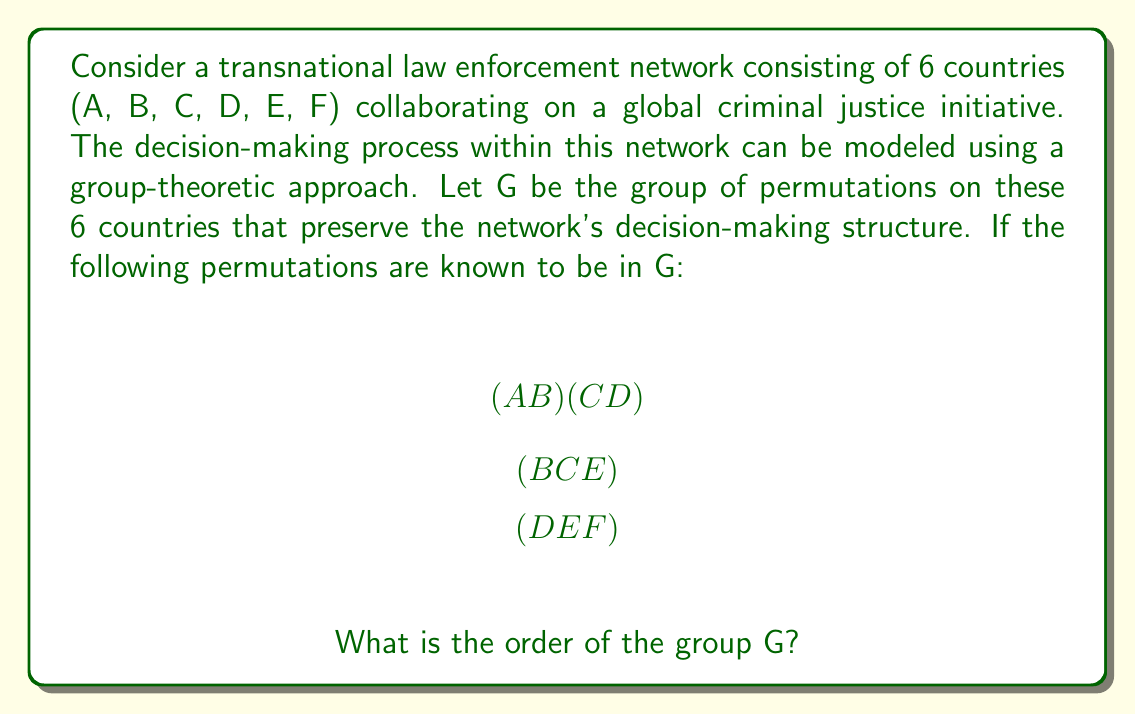Can you answer this question? To solve this problem, we need to analyze the given permutations and determine the full structure of the group G. Let's approach this step-by-step:

1. First, we identify the generators of the group:
   $\alpha = (A B)(C D)$
   $\beta = (B C E)$
   $\gamma = (D E F)$

2. We need to find all elements generated by these permutations. Let's start by computing their powers:

   $\alpha^2 = e$ (identity)
   $\beta^3 = e$
   $\gamma^3 = e$

3. Now, let's consider the products of these permutations:

   $\alpha \beta = (A B)(C D)(B C E) = (A C E B D)$
   $\alpha \gamma = (A B)(C D)(D E F) = (A B)(C E F)$
   $\beta \gamma = (B C E)(D E F) = (B C E D F)$

4. We can see that $\alpha \beta$ is a 5-cycle, which means it generates 5 elements.
   $(\alpha \beta)^5 = e$

5. The permutation $\alpha \gamma$ is a product of two disjoint cycles, one of length 2 and one of length 3.
   $(\alpha \gamma)^6 = e$

6. The permutation $\beta \gamma$ is a 5-cycle, similar to $\alpha \beta$.
   $(\beta \gamma)^5 = e$

7. Considering all these permutations and their products, we can see that G contains all possible permutations of the 6 countries.

8. Therefore, G is isomorphic to S_6, the symmetric group on 6 elements.

9. The order of S_6 is 6! = 6 × 5 × 4 × 3 × 2 × 1 = 720.

Thus, the order of group G is 720.
Answer: 720 